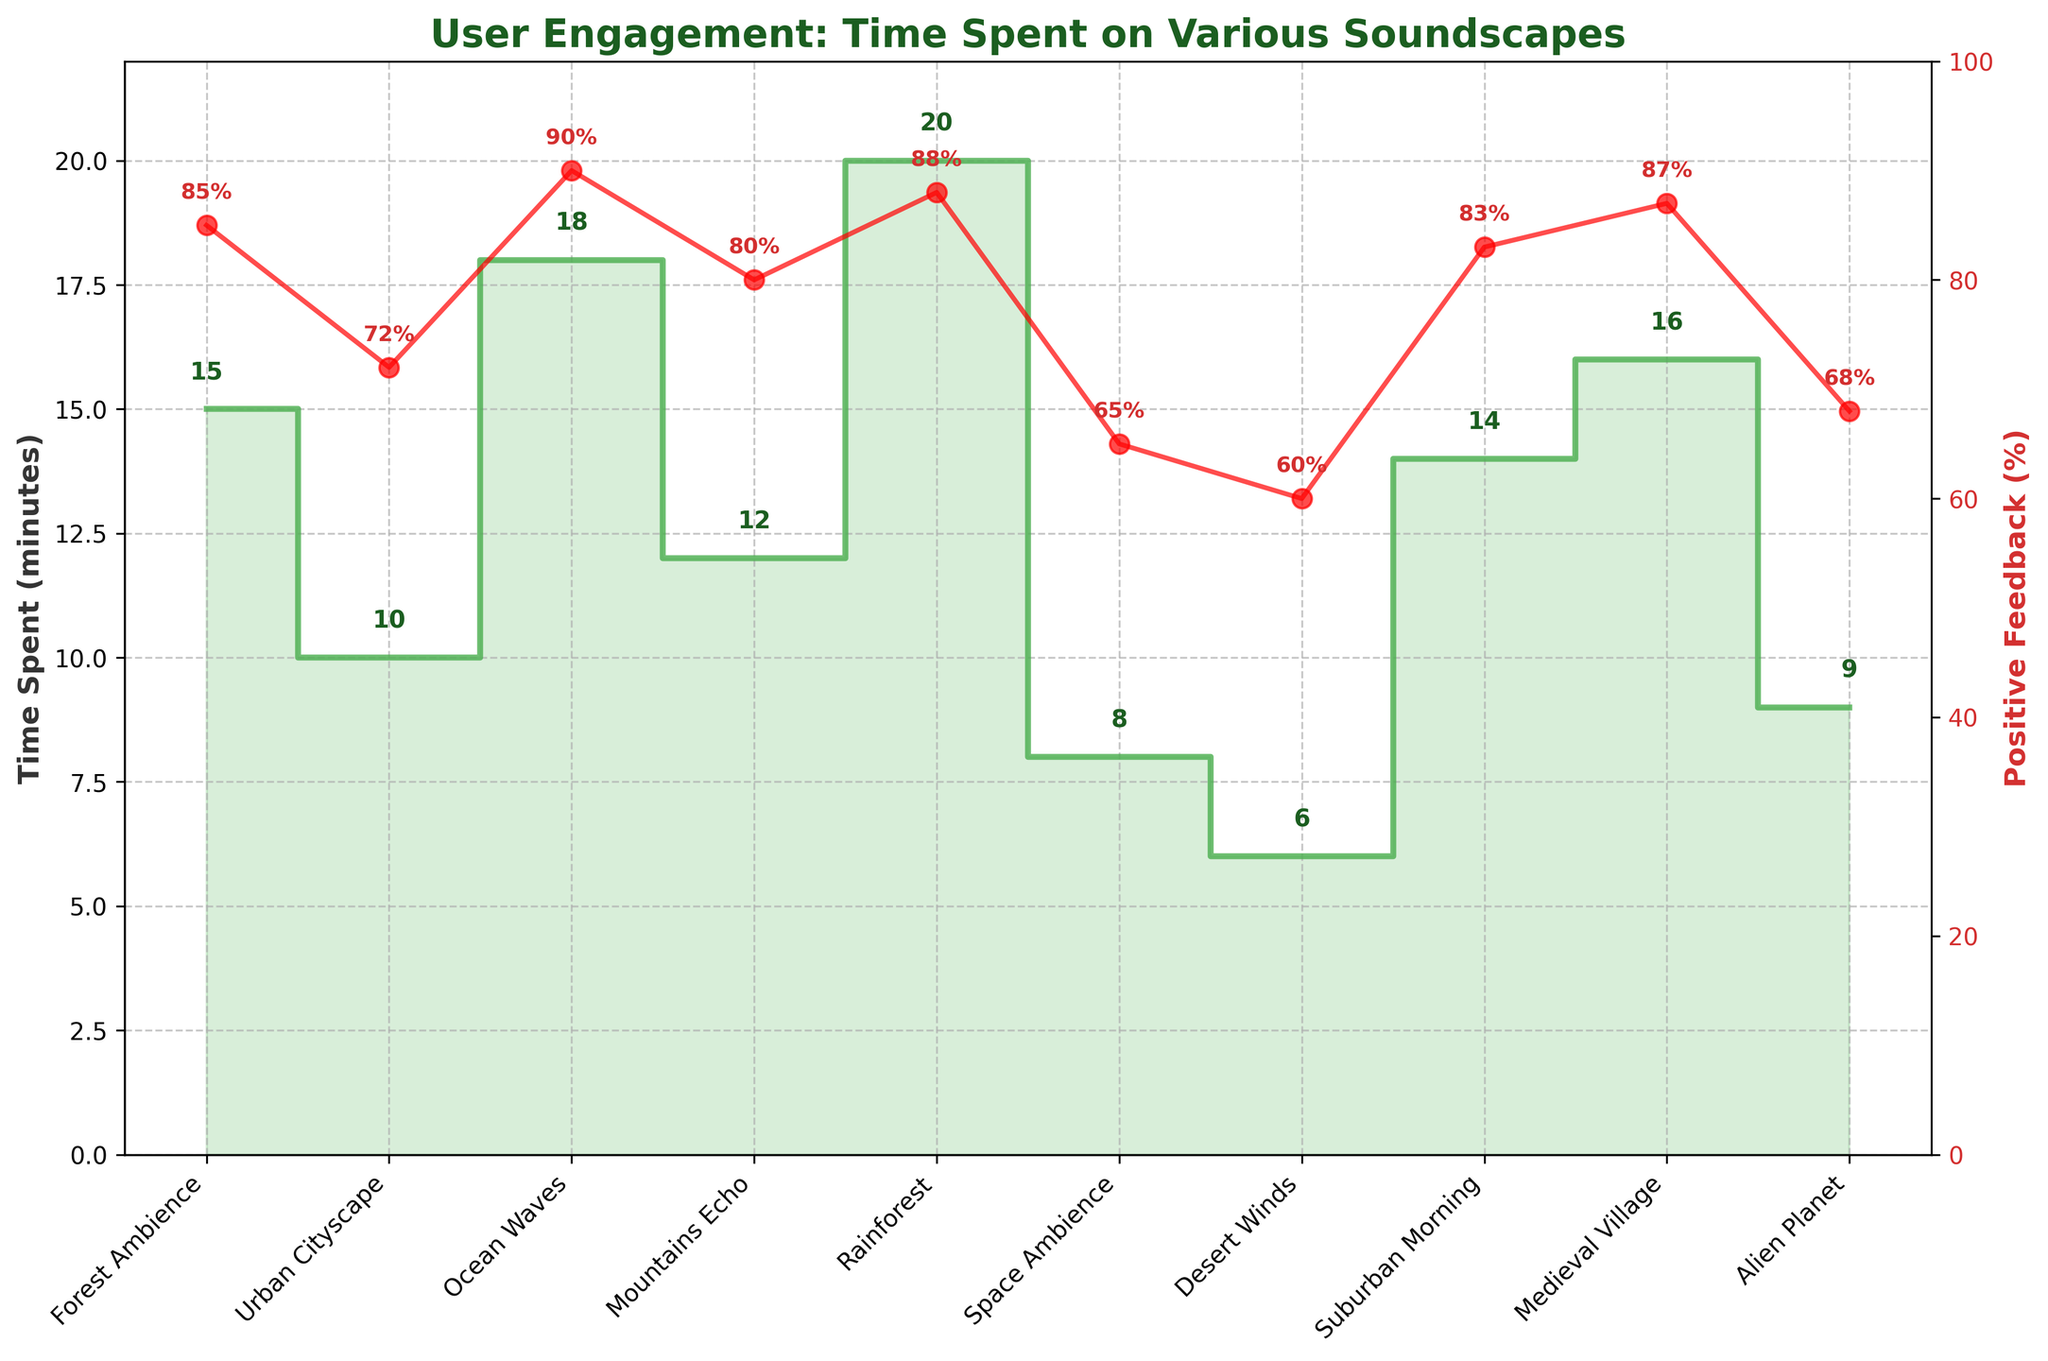What is the title of the plot? The title of the plot is found at the top center of the figure. It is usually in a larger and bold font. The title is "User Engagement: Time Spent on Various Soundscapes".
Answer: User Engagement: Time Spent on Various Soundscapes Which soundscape has the highest time spent? By examining the plot, identify which soundscape reaches the highest point on the y-axis labeled 'Time Spent (minutes)'. This is the 'Rainforest' soundscape with 20 minutes.
Answer: Rainforest What is the positive feedback percentage for the 'Alien Planet' soundscape? Locate 'Alien Planet' on the x-axis and follow its corresponding data point on the second y-axis labeled 'Positive Feedback (%)', which is indicated in red. The value shown near the data point is 68%.
Answer: 68% How much time did users spend on 'Suburban Morning' compared to 'Mountains Echo'? Identify the values for 'Suburban Morning' and 'Mountains Echo' on the plot. 'Suburban Morning' shows 14 minutes and 'Mountains Echo' shows 12 minutes. Calculate the difference: 14 - 12 = 2 minutes.
Answer: 2 minutes Which soundscape received the lowest time spent and what was it? Locate the lowest step on the y-axis labeled 'Time Spent (minutes)'. The 'Desert Winds' soundscape has the lowest time spent of 6 minutes.
Answer: Desert Winds, 6 minutes What is the average positive feedback (%) across all soundscapes? Add up all the positive feedback percentages and divide by the number of soundscapes. The values are: 85, 72, 90, 80, 88, 65, 60, 83, 87, 68. The sum is 778, and there are 10 soundscapes. Therefore, 778 / 10 = 77.8%.
Answer: 77.8% Which soundscape has a higher positive feedback percentage, ‘Urban Cityscape’ or ‘Space Ambience’? Compare the positive feedback percentages for both soundscapes. 'Urban Cityscape' has 72% and 'Space Ambience' has 65%. Thus, 'Urban Cityscape' is higher.
Answer: Urban Cityscape How does the 'Medieval Village' soundscape compare to the 'Forest Ambience' in terms of positive feedback? Identify the positive feedback percentages for 'Medieval Village' (87%) and 'Forest Ambience' (85%). 'Medieval Village' has higher positive feedback by 2%.
Answer: Medieval Village is higher by 2% Which two soundscapes have exactly 9 positive feedback percentages? From the plot, locate the data points for positive feedback percentages associated with y-axis values. Here, 'Mountains Echo' has a positive feedback of 80%, and 'Alien Planet' has a positive feedback of 68%. For both instances, the feedback percentages are 9.
Answer: Mountains Echo, Alien Planet 